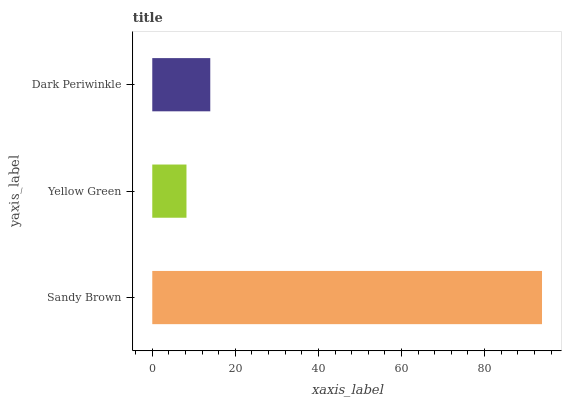Is Yellow Green the minimum?
Answer yes or no. Yes. Is Sandy Brown the maximum?
Answer yes or no. Yes. Is Dark Periwinkle the minimum?
Answer yes or no. No. Is Dark Periwinkle the maximum?
Answer yes or no. No. Is Dark Periwinkle greater than Yellow Green?
Answer yes or no. Yes. Is Yellow Green less than Dark Periwinkle?
Answer yes or no. Yes. Is Yellow Green greater than Dark Periwinkle?
Answer yes or no. No. Is Dark Periwinkle less than Yellow Green?
Answer yes or no. No. Is Dark Periwinkle the high median?
Answer yes or no. Yes. Is Dark Periwinkle the low median?
Answer yes or no. Yes. Is Yellow Green the high median?
Answer yes or no. No. Is Yellow Green the low median?
Answer yes or no. No. 